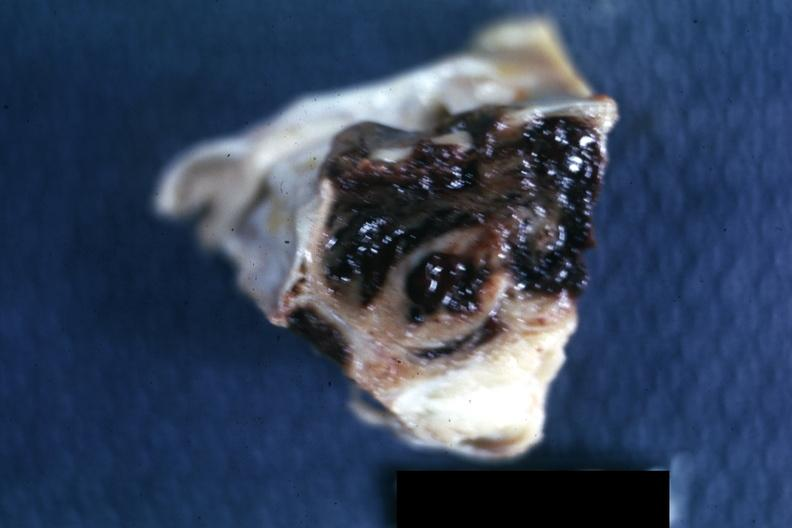what does this image show?
Answer the question using a single word or phrase. Excised sella 